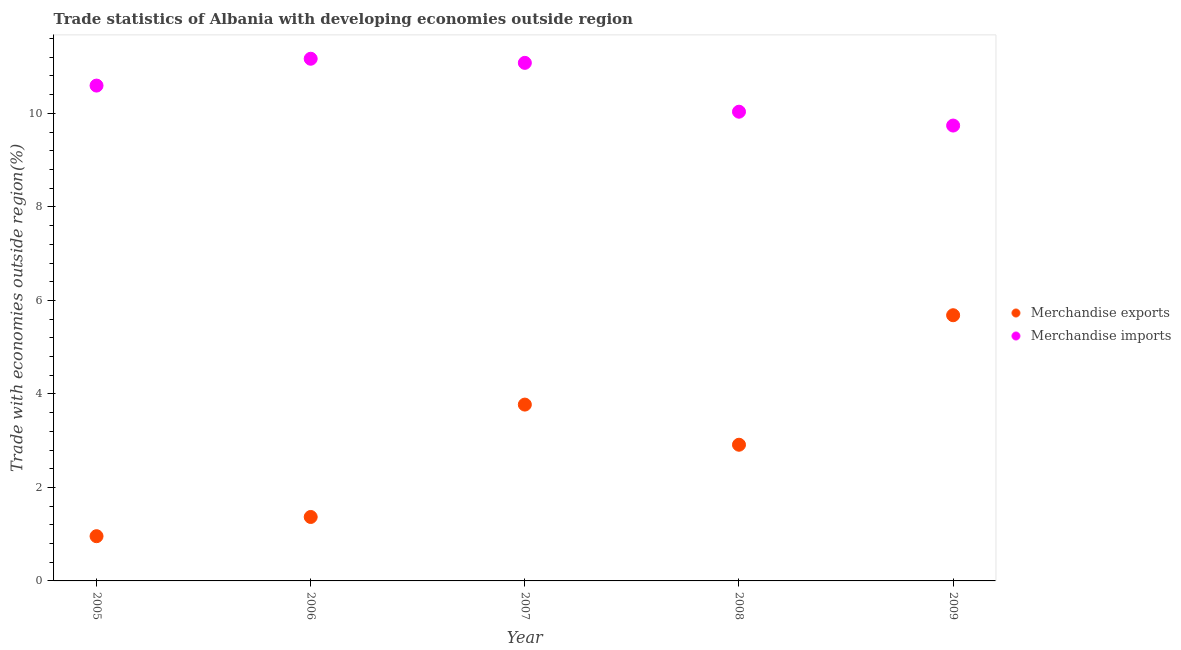How many different coloured dotlines are there?
Your answer should be very brief. 2. What is the merchandise imports in 2007?
Ensure brevity in your answer.  11.08. Across all years, what is the maximum merchandise imports?
Your answer should be compact. 11.17. Across all years, what is the minimum merchandise imports?
Ensure brevity in your answer.  9.74. What is the total merchandise imports in the graph?
Your response must be concise. 52.62. What is the difference between the merchandise imports in 2006 and that in 2008?
Your response must be concise. 1.13. What is the difference between the merchandise exports in 2005 and the merchandise imports in 2008?
Make the answer very short. -9.08. What is the average merchandise imports per year?
Offer a terse response. 10.52. In the year 2006, what is the difference between the merchandise imports and merchandise exports?
Keep it short and to the point. 9.8. In how many years, is the merchandise imports greater than 9.6 %?
Ensure brevity in your answer.  5. What is the ratio of the merchandise imports in 2007 to that in 2008?
Offer a very short reply. 1.1. Is the merchandise imports in 2006 less than that in 2009?
Provide a short and direct response. No. Is the difference between the merchandise imports in 2006 and 2009 greater than the difference between the merchandise exports in 2006 and 2009?
Provide a short and direct response. Yes. What is the difference between the highest and the second highest merchandise imports?
Offer a very short reply. 0.09. What is the difference between the highest and the lowest merchandise imports?
Give a very brief answer. 1.43. Is the merchandise exports strictly greater than the merchandise imports over the years?
Offer a terse response. No. How many dotlines are there?
Make the answer very short. 2. How many years are there in the graph?
Offer a very short reply. 5. What is the difference between two consecutive major ticks on the Y-axis?
Your answer should be very brief. 2. Are the values on the major ticks of Y-axis written in scientific E-notation?
Provide a succinct answer. No. Does the graph contain any zero values?
Your answer should be very brief. No. How many legend labels are there?
Your answer should be very brief. 2. What is the title of the graph?
Give a very brief answer. Trade statistics of Albania with developing economies outside region. Does "Import" appear as one of the legend labels in the graph?
Your answer should be compact. No. What is the label or title of the X-axis?
Offer a terse response. Year. What is the label or title of the Y-axis?
Your answer should be compact. Trade with economies outside region(%). What is the Trade with economies outside region(%) of Merchandise exports in 2005?
Ensure brevity in your answer.  0.96. What is the Trade with economies outside region(%) in Merchandise imports in 2005?
Keep it short and to the point. 10.59. What is the Trade with economies outside region(%) of Merchandise exports in 2006?
Keep it short and to the point. 1.37. What is the Trade with economies outside region(%) in Merchandise imports in 2006?
Offer a terse response. 11.17. What is the Trade with economies outside region(%) in Merchandise exports in 2007?
Offer a terse response. 3.77. What is the Trade with economies outside region(%) in Merchandise imports in 2007?
Make the answer very short. 11.08. What is the Trade with economies outside region(%) of Merchandise exports in 2008?
Provide a succinct answer. 2.91. What is the Trade with economies outside region(%) of Merchandise imports in 2008?
Provide a short and direct response. 10.04. What is the Trade with economies outside region(%) of Merchandise exports in 2009?
Give a very brief answer. 5.68. What is the Trade with economies outside region(%) of Merchandise imports in 2009?
Give a very brief answer. 9.74. Across all years, what is the maximum Trade with economies outside region(%) of Merchandise exports?
Provide a short and direct response. 5.68. Across all years, what is the maximum Trade with economies outside region(%) of Merchandise imports?
Offer a terse response. 11.17. Across all years, what is the minimum Trade with economies outside region(%) in Merchandise exports?
Provide a short and direct response. 0.96. Across all years, what is the minimum Trade with economies outside region(%) of Merchandise imports?
Your answer should be compact. 9.74. What is the total Trade with economies outside region(%) of Merchandise exports in the graph?
Ensure brevity in your answer.  14.69. What is the total Trade with economies outside region(%) in Merchandise imports in the graph?
Your answer should be compact. 52.62. What is the difference between the Trade with economies outside region(%) of Merchandise exports in 2005 and that in 2006?
Offer a very short reply. -0.41. What is the difference between the Trade with economies outside region(%) in Merchandise imports in 2005 and that in 2006?
Offer a terse response. -0.57. What is the difference between the Trade with economies outside region(%) of Merchandise exports in 2005 and that in 2007?
Offer a terse response. -2.81. What is the difference between the Trade with economies outside region(%) of Merchandise imports in 2005 and that in 2007?
Give a very brief answer. -0.49. What is the difference between the Trade with economies outside region(%) of Merchandise exports in 2005 and that in 2008?
Your response must be concise. -1.96. What is the difference between the Trade with economies outside region(%) in Merchandise imports in 2005 and that in 2008?
Your answer should be compact. 0.56. What is the difference between the Trade with economies outside region(%) of Merchandise exports in 2005 and that in 2009?
Your answer should be very brief. -4.73. What is the difference between the Trade with economies outside region(%) in Merchandise imports in 2005 and that in 2009?
Your answer should be compact. 0.85. What is the difference between the Trade with economies outside region(%) in Merchandise exports in 2006 and that in 2007?
Give a very brief answer. -2.4. What is the difference between the Trade with economies outside region(%) in Merchandise imports in 2006 and that in 2007?
Give a very brief answer. 0.09. What is the difference between the Trade with economies outside region(%) in Merchandise exports in 2006 and that in 2008?
Offer a very short reply. -1.54. What is the difference between the Trade with economies outside region(%) in Merchandise imports in 2006 and that in 2008?
Your answer should be very brief. 1.13. What is the difference between the Trade with economies outside region(%) of Merchandise exports in 2006 and that in 2009?
Ensure brevity in your answer.  -4.32. What is the difference between the Trade with economies outside region(%) of Merchandise imports in 2006 and that in 2009?
Make the answer very short. 1.43. What is the difference between the Trade with economies outside region(%) of Merchandise exports in 2007 and that in 2008?
Offer a terse response. 0.86. What is the difference between the Trade with economies outside region(%) of Merchandise imports in 2007 and that in 2008?
Make the answer very short. 1.04. What is the difference between the Trade with economies outside region(%) of Merchandise exports in 2007 and that in 2009?
Your response must be concise. -1.91. What is the difference between the Trade with economies outside region(%) in Merchandise imports in 2007 and that in 2009?
Offer a very short reply. 1.34. What is the difference between the Trade with economies outside region(%) in Merchandise exports in 2008 and that in 2009?
Keep it short and to the point. -2.77. What is the difference between the Trade with economies outside region(%) in Merchandise imports in 2008 and that in 2009?
Give a very brief answer. 0.3. What is the difference between the Trade with economies outside region(%) of Merchandise exports in 2005 and the Trade with economies outside region(%) of Merchandise imports in 2006?
Ensure brevity in your answer.  -10.21. What is the difference between the Trade with economies outside region(%) in Merchandise exports in 2005 and the Trade with economies outside region(%) in Merchandise imports in 2007?
Your answer should be very brief. -10.12. What is the difference between the Trade with economies outside region(%) of Merchandise exports in 2005 and the Trade with economies outside region(%) of Merchandise imports in 2008?
Make the answer very short. -9.08. What is the difference between the Trade with economies outside region(%) of Merchandise exports in 2005 and the Trade with economies outside region(%) of Merchandise imports in 2009?
Give a very brief answer. -8.78. What is the difference between the Trade with economies outside region(%) of Merchandise exports in 2006 and the Trade with economies outside region(%) of Merchandise imports in 2007?
Give a very brief answer. -9.71. What is the difference between the Trade with economies outside region(%) of Merchandise exports in 2006 and the Trade with economies outside region(%) of Merchandise imports in 2008?
Your answer should be very brief. -8.67. What is the difference between the Trade with economies outside region(%) of Merchandise exports in 2006 and the Trade with economies outside region(%) of Merchandise imports in 2009?
Your response must be concise. -8.37. What is the difference between the Trade with economies outside region(%) of Merchandise exports in 2007 and the Trade with economies outside region(%) of Merchandise imports in 2008?
Your answer should be compact. -6.26. What is the difference between the Trade with economies outside region(%) of Merchandise exports in 2007 and the Trade with economies outside region(%) of Merchandise imports in 2009?
Ensure brevity in your answer.  -5.97. What is the difference between the Trade with economies outside region(%) in Merchandise exports in 2008 and the Trade with economies outside region(%) in Merchandise imports in 2009?
Make the answer very short. -6.83. What is the average Trade with economies outside region(%) of Merchandise exports per year?
Keep it short and to the point. 2.94. What is the average Trade with economies outside region(%) in Merchandise imports per year?
Your answer should be compact. 10.52. In the year 2005, what is the difference between the Trade with economies outside region(%) of Merchandise exports and Trade with economies outside region(%) of Merchandise imports?
Your answer should be compact. -9.64. In the year 2006, what is the difference between the Trade with economies outside region(%) of Merchandise exports and Trade with economies outside region(%) of Merchandise imports?
Your answer should be compact. -9.8. In the year 2007, what is the difference between the Trade with economies outside region(%) of Merchandise exports and Trade with economies outside region(%) of Merchandise imports?
Your response must be concise. -7.31. In the year 2008, what is the difference between the Trade with economies outside region(%) in Merchandise exports and Trade with economies outside region(%) in Merchandise imports?
Give a very brief answer. -7.12. In the year 2009, what is the difference between the Trade with economies outside region(%) of Merchandise exports and Trade with economies outside region(%) of Merchandise imports?
Provide a succinct answer. -4.06. What is the ratio of the Trade with economies outside region(%) of Merchandise exports in 2005 to that in 2006?
Keep it short and to the point. 0.7. What is the ratio of the Trade with economies outside region(%) of Merchandise imports in 2005 to that in 2006?
Your answer should be compact. 0.95. What is the ratio of the Trade with economies outside region(%) of Merchandise exports in 2005 to that in 2007?
Provide a succinct answer. 0.25. What is the ratio of the Trade with economies outside region(%) of Merchandise imports in 2005 to that in 2007?
Offer a terse response. 0.96. What is the ratio of the Trade with economies outside region(%) in Merchandise exports in 2005 to that in 2008?
Provide a succinct answer. 0.33. What is the ratio of the Trade with economies outside region(%) in Merchandise imports in 2005 to that in 2008?
Keep it short and to the point. 1.06. What is the ratio of the Trade with economies outside region(%) of Merchandise exports in 2005 to that in 2009?
Your answer should be very brief. 0.17. What is the ratio of the Trade with economies outside region(%) in Merchandise imports in 2005 to that in 2009?
Keep it short and to the point. 1.09. What is the ratio of the Trade with economies outside region(%) in Merchandise exports in 2006 to that in 2007?
Ensure brevity in your answer.  0.36. What is the ratio of the Trade with economies outside region(%) in Merchandise imports in 2006 to that in 2007?
Your response must be concise. 1.01. What is the ratio of the Trade with economies outside region(%) of Merchandise exports in 2006 to that in 2008?
Offer a very short reply. 0.47. What is the ratio of the Trade with economies outside region(%) of Merchandise imports in 2006 to that in 2008?
Ensure brevity in your answer.  1.11. What is the ratio of the Trade with economies outside region(%) in Merchandise exports in 2006 to that in 2009?
Offer a terse response. 0.24. What is the ratio of the Trade with economies outside region(%) in Merchandise imports in 2006 to that in 2009?
Keep it short and to the point. 1.15. What is the ratio of the Trade with economies outside region(%) of Merchandise exports in 2007 to that in 2008?
Provide a short and direct response. 1.29. What is the ratio of the Trade with economies outside region(%) of Merchandise imports in 2007 to that in 2008?
Provide a short and direct response. 1.1. What is the ratio of the Trade with economies outside region(%) of Merchandise exports in 2007 to that in 2009?
Ensure brevity in your answer.  0.66. What is the ratio of the Trade with economies outside region(%) in Merchandise imports in 2007 to that in 2009?
Make the answer very short. 1.14. What is the ratio of the Trade with economies outside region(%) of Merchandise exports in 2008 to that in 2009?
Your answer should be very brief. 0.51. What is the ratio of the Trade with economies outside region(%) in Merchandise imports in 2008 to that in 2009?
Ensure brevity in your answer.  1.03. What is the difference between the highest and the second highest Trade with economies outside region(%) in Merchandise exports?
Offer a very short reply. 1.91. What is the difference between the highest and the second highest Trade with economies outside region(%) of Merchandise imports?
Keep it short and to the point. 0.09. What is the difference between the highest and the lowest Trade with economies outside region(%) in Merchandise exports?
Make the answer very short. 4.73. What is the difference between the highest and the lowest Trade with economies outside region(%) in Merchandise imports?
Make the answer very short. 1.43. 